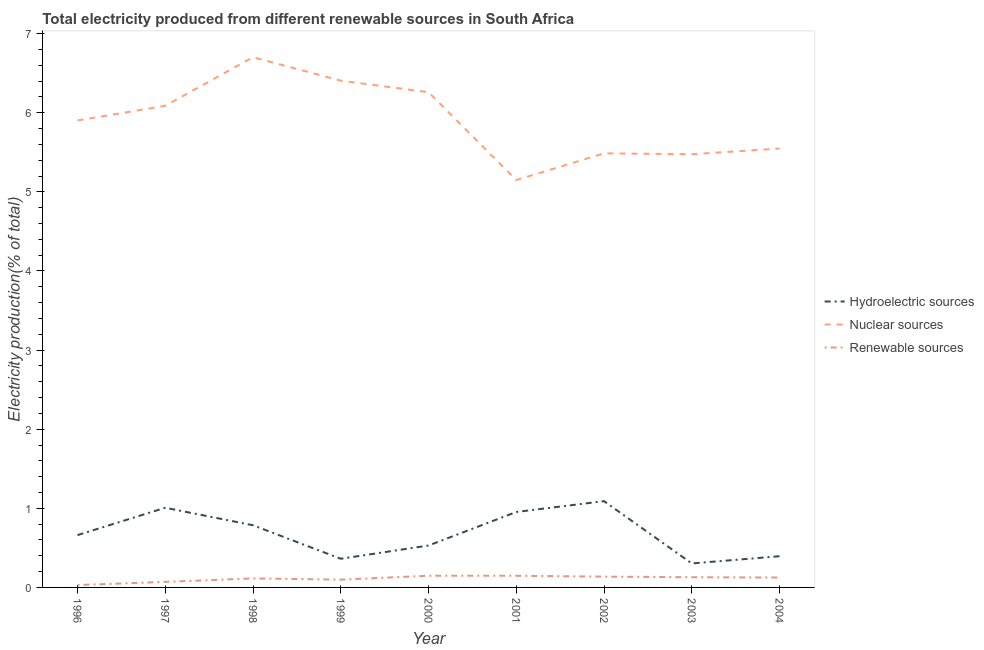Does the line corresponding to percentage of electricity produced by renewable sources intersect with the line corresponding to percentage of electricity produced by hydroelectric sources?
Make the answer very short. No. Is the number of lines equal to the number of legend labels?
Your answer should be very brief. Yes. What is the percentage of electricity produced by hydroelectric sources in 2002?
Provide a succinct answer. 1.09. Across all years, what is the maximum percentage of electricity produced by renewable sources?
Your response must be concise. 0.15. Across all years, what is the minimum percentage of electricity produced by nuclear sources?
Your response must be concise. 5.15. In which year was the percentage of electricity produced by renewable sources minimum?
Offer a terse response. 1996. What is the total percentage of electricity produced by hydroelectric sources in the graph?
Your answer should be compact. 6.09. What is the difference between the percentage of electricity produced by nuclear sources in 1997 and that in 2001?
Ensure brevity in your answer.  0.94. What is the difference between the percentage of electricity produced by renewable sources in 1997 and the percentage of electricity produced by hydroelectric sources in 1998?
Offer a very short reply. -0.72. What is the average percentage of electricity produced by hydroelectric sources per year?
Offer a very short reply. 0.68. In the year 1997, what is the difference between the percentage of electricity produced by hydroelectric sources and percentage of electricity produced by renewable sources?
Ensure brevity in your answer.  0.94. In how many years, is the percentage of electricity produced by hydroelectric sources greater than 2.8 %?
Your answer should be compact. 0. What is the ratio of the percentage of electricity produced by hydroelectric sources in 1996 to that in 1998?
Provide a succinct answer. 0.84. Is the percentage of electricity produced by nuclear sources in 2000 less than that in 2004?
Make the answer very short. No. What is the difference between the highest and the second highest percentage of electricity produced by hydroelectric sources?
Your response must be concise. 0.08. What is the difference between the highest and the lowest percentage of electricity produced by renewable sources?
Ensure brevity in your answer.  0.12. In how many years, is the percentage of electricity produced by hydroelectric sources greater than the average percentage of electricity produced by hydroelectric sources taken over all years?
Offer a very short reply. 4. Is the sum of the percentage of electricity produced by nuclear sources in 1998 and 1999 greater than the maximum percentage of electricity produced by hydroelectric sources across all years?
Your response must be concise. Yes. Does the percentage of electricity produced by hydroelectric sources monotonically increase over the years?
Provide a short and direct response. No. Is the percentage of electricity produced by renewable sources strictly greater than the percentage of electricity produced by hydroelectric sources over the years?
Keep it short and to the point. No. Is the percentage of electricity produced by nuclear sources strictly less than the percentage of electricity produced by hydroelectric sources over the years?
Offer a very short reply. No. How many lines are there?
Give a very brief answer. 3. How many years are there in the graph?
Offer a very short reply. 9. Are the values on the major ticks of Y-axis written in scientific E-notation?
Your answer should be compact. No. Does the graph contain any zero values?
Make the answer very short. No. How many legend labels are there?
Provide a short and direct response. 3. What is the title of the graph?
Offer a terse response. Total electricity produced from different renewable sources in South Africa. Does "Liquid fuel" appear as one of the legend labels in the graph?
Offer a terse response. No. What is the label or title of the X-axis?
Your answer should be compact. Year. What is the Electricity production(% of total) of Hydroelectric sources in 1996?
Make the answer very short. 0.66. What is the Electricity production(% of total) of Nuclear sources in 1996?
Offer a terse response. 5.9. What is the Electricity production(% of total) in Renewable sources in 1996?
Your answer should be compact. 0.03. What is the Electricity production(% of total) of Hydroelectric sources in 1997?
Ensure brevity in your answer.  1.01. What is the Electricity production(% of total) of Nuclear sources in 1997?
Provide a short and direct response. 6.09. What is the Electricity production(% of total) of Renewable sources in 1997?
Your answer should be very brief. 0.07. What is the Electricity production(% of total) of Hydroelectric sources in 1998?
Give a very brief answer. 0.79. What is the Electricity production(% of total) in Nuclear sources in 1998?
Give a very brief answer. 6.7. What is the Electricity production(% of total) of Renewable sources in 1998?
Make the answer very short. 0.11. What is the Electricity production(% of total) in Hydroelectric sources in 1999?
Offer a terse response. 0.36. What is the Electricity production(% of total) of Nuclear sources in 1999?
Give a very brief answer. 6.4. What is the Electricity production(% of total) in Renewable sources in 1999?
Make the answer very short. 0.1. What is the Electricity production(% of total) of Hydroelectric sources in 2000?
Provide a short and direct response. 0.53. What is the Electricity production(% of total) in Nuclear sources in 2000?
Your answer should be compact. 6.26. What is the Electricity production(% of total) in Renewable sources in 2000?
Keep it short and to the point. 0.15. What is the Electricity production(% of total) in Hydroelectric sources in 2001?
Provide a short and direct response. 0.95. What is the Electricity production(% of total) of Nuclear sources in 2001?
Ensure brevity in your answer.  5.15. What is the Electricity production(% of total) in Renewable sources in 2001?
Make the answer very short. 0.15. What is the Electricity production(% of total) in Hydroelectric sources in 2002?
Provide a short and direct response. 1.09. What is the Electricity production(% of total) of Nuclear sources in 2002?
Keep it short and to the point. 5.49. What is the Electricity production(% of total) in Renewable sources in 2002?
Give a very brief answer. 0.14. What is the Electricity production(% of total) of Hydroelectric sources in 2003?
Provide a short and direct response. 0.3. What is the Electricity production(% of total) of Nuclear sources in 2003?
Give a very brief answer. 5.48. What is the Electricity production(% of total) of Renewable sources in 2003?
Ensure brevity in your answer.  0.13. What is the Electricity production(% of total) of Hydroelectric sources in 2004?
Your response must be concise. 0.39. What is the Electricity production(% of total) in Nuclear sources in 2004?
Your answer should be compact. 5.55. What is the Electricity production(% of total) of Renewable sources in 2004?
Offer a very short reply. 0.12. Across all years, what is the maximum Electricity production(% of total) of Hydroelectric sources?
Give a very brief answer. 1.09. Across all years, what is the maximum Electricity production(% of total) of Nuclear sources?
Your response must be concise. 6.7. Across all years, what is the maximum Electricity production(% of total) in Renewable sources?
Provide a short and direct response. 0.15. Across all years, what is the minimum Electricity production(% of total) of Hydroelectric sources?
Your response must be concise. 0.3. Across all years, what is the minimum Electricity production(% of total) in Nuclear sources?
Your answer should be very brief. 5.15. Across all years, what is the minimum Electricity production(% of total) in Renewable sources?
Your answer should be very brief. 0.03. What is the total Electricity production(% of total) of Hydroelectric sources in the graph?
Provide a short and direct response. 6.09. What is the total Electricity production(% of total) of Nuclear sources in the graph?
Make the answer very short. 53.01. What is the difference between the Electricity production(% of total) in Hydroelectric sources in 1996 and that in 1997?
Your answer should be compact. -0.35. What is the difference between the Electricity production(% of total) in Nuclear sources in 1996 and that in 1997?
Offer a very short reply. -0.19. What is the difference between the Electricity production(% of total) in Renewable sources in 1996 and that in 1997?
Keep it short and to the point. -0.04. What is the difference between the Electricity production(% of total) of Hydroelectric sources in 1996 and that in 1998?
Ensure brevity in your answer.  -0.12. What is the difference between the Electricity production(% of total) of Nuclear sources in 1996 and that in 1998?
Offer a terse response. -0.8. What is the difference between the Electricity production(% of total) of Renewable sources in 1996 and that in 1998?
Your answer should be compact. -0.08. What is the difference between the Electricity production(% of total) of Hydroelectric sources in 1996 and that in 1999?
Provide a succinct answer. 0.3. What is the difference between the Electricity production(% of total) in Nuclear sources in 1996 and that in 1999?
Give a very brief answer. -0.5. What is the difference between the Electricity production(% of total) in Renewable sources in 1996 and that in 1999?
Your answer should be compact. -0.07. What is the difference between the Electricity production(% of total) of Hydroelectric sources in 1996 and that in 2000?
Provide a succinct answer. 0.13. What is the difference between the Electricity production(% of total) of Nuclear sources in 1996 and that in 2000?
Give a very brief answer. -0.36. What is the difference between the Electricity production(% of total) in Renewable sources in 1996 and that in 2000?
Keep it short and to the point. -0.12. What is the difference between the Electricity production(% of total) in Hydroelectric sources in 1996 and that in 2001?
Your answer should be compact. -0.29. What is the difference between the Electricity production(% of total) of Nuclear sources in 1996 and that in 2001?
Ensure brevity in your answer.  0.75. What is the difference between the Electricity production(% of total) in Renewable sources in 1996 and that in 2001?
Provide a succinct answer. -0.12. What is the difference between the Electricity production(% of total) in Hydroelectric sources in 1996 and that in 2002?
Your answer should be compact. -0.43. What is the difference between the Electricity production(% of total) in Nuclear sources in 1996 and that in 2002?
Keep it short and to the point. 0.42. What is the difference between the Electricity production(% of total) of Renewable sources in 1996 and that in 2002?
Your answer should be compact. -0.11. What is the difference between the Electricity production(% of total) in Hydroelectric sources in 1996 and that in 2003?
Offer a very short reply. 0.36. What is the difference between the Electricity production(% of total) in Nuclear sources in 1996 and that in 2003?
Provide a short and direct response. 0.43. What is the difference between the Electricity production(% of total) in Renewable sources in 1996 and that in 2003?
Give a very brief answer. -0.1. What is the difference between the Electricity production(% of total) of Hydroelectric sources in 1996 and that in 2004?
Offer a very short reply. 0.27. What is the difference between the Electricity production(% of total) of Nuclear sources in 1996 and that in 2004?
Your response must be concise. 0.36. What is the difference between the Electricity production(% of total) in Renewable sources in 1996 and that in 2004?
Ensure brevity in your answer.  -0.09. What is the difference between the Electricity production(% of total) of Hydroelectric sources in 1997 and that in 1998?
Make the answer very short. 0.22. What is the difference between the Electricity production(% of total) in Nuclear sources in 1997 and that in 1998?
Your response must be concise. -0.61. What is the difference between the Electricity production(% of total) of Renewable sources in 1997 and that in 1998?
Offer a very short reply. -0.04. What is the difference between the Electricity production(% of total) in Hydroelectric sources in 1997 and that in 1999?
Provide a succinct answer. 0.64. What is the difference between the Electricity production(% of total) of Nuclear sources in 1997 and that in 1999?
Offer a very short reply. -0.32. What is the difference between the Electricity production(% of total) in Renewable sources in 1997 and that in 1999?
Provide a short and direct response. -0.03. What is the difference between the Electricity production(% of total) in Hydroelectric sources in 1997 and that in 2000?
Your response must be concise. 0.48. What is the difference between the Electricity production(% of total) in Nuclear sources in 1997 and that in 2000?
Offer a terse response. -0.17. What is the difference between the Electricity production(% of total) of Renewable sources in 1997 and that in 2000?
Keep it short and to the point. -0.08. What is the difference between the Electricity production(% of total) of Hydroelectric sources in 1997 and that in 2001?
Provide a succinct answer. 0.05. What is the difference between the Electricity production(% of total) in Nuclear sources in 1997 and that in 2001?
Your answer should be compact. 0.94. What is the difference between the Electricity production(% of total) in Renewable sources in 1997 and that in 2001?
Provide a short and direct response. -0.08. What is the difference between the Electricity production(% of total) of Hydroelectric sources in 1997 and that in 2002?
Provide a short and direct response. -0.08. What is the difference between the Electricity production(% of total) of Nuclear sources in 1997 and that in 2002?
Provide a succinct answer. 0.6. What is the difference between the Electricity production(% of total) of Renewable sources in 1997 and that in 2002?
Your answer should be very brief. -0.07. What is the difference between the Electricity production(% of total) in Hydroelectric sources in 1997 and that in 2003?
Give a very brief answer. 0.7. What is the difference between the Electricity production(% of total) of Nuclear sources in 1997 and that in 2003?
Offer a terse response. 0.61. What is the difference between the Electricity production(% of total) in Renewable sources in 1997 and that in 2003?
Provide a short and direct response. -0.06. What is the difference between the Electricity production(% of total) in Hydroelectric sources in 1997 and that in 2004?
Your response must be concise. 0.61. What is the difference between the Electricity production(% of total) of Nuclear sources in 1997 and that in 2004?
Offer a very short reply. 0.54. What is the difference between the Electricity production(% of total) of Renewable sources in 1997 and that in 2004?
Make the answer very short. -0.05. What is the difference between the Electricity production(% of total) of Hydroelectric sources in 1998 and that in 1999?
Make the answer very short. 0.42. What is the difference between the Electricity production(% of total) of Nuclear sources in 1998 and that in 1999?
Provide a succinct answer. 0.3. What is the difference between the Electricity production(% of total) of Renewable sources in 1998 and that in 1999?
Your response must be concise. 0.02. What is the difference between the Electricity production(% of total) in Hydroelectric sources in 1998 and that in 2000?
Ensure brevity in your answer.  0.26. What is the difference between the Electricity production(% of total) of Nuclear sources in 1998 and that in 2000?
Keep it short and to the point. 0.44. What is the difference between the Electricity production(% of total) in Renewable sources in 1998 and that in 2000?
Your answer should be compact. -0.03. What is the difference between the Electricity production(% of total) in Hydroelectric sources in 1998 and that in 2001?
Provide a short and direct response. -0.17. What is the difference between the Electricity production(% of total) of Nuclear sources in 1998 and that in 2001?
Ensure brevity in your answer.  1.55. What is the difference between the Electricity production(% of total) in Renewable sources in 1998 and that in 2001?
Offer a terse response. -0.03. What is the difference between the Electricity production(% of total) of Hydroelectric sources in 1998 and that in 2002?
Your answer should be very brief. -0.3. What is the difference between the Electricity production(% of total) of Nuclear sources in 1998 and that in 2002?
Provide a succinct answer. 1.22. What is the difference between the Electricity production(% of total) in Renewable sources in 1998 and that in 2002?
Your answer should be very brief. -0.02. What is the difference between the Electricity production(% of total) in Hydroelectric sources in 1998 and that in 2003?
Make the answer very short. 0.48. What is the difference between the Electricity production(% of total) in Nuclear sources in 1998 and that in 2003?
Ensure brevity in your answer.  1.23. What is the difference between the Electricity production(% of total) in Renewable sources in 1998 and that in 2003?
Your answer should be compact. -0.01. What is the difference between the Electricity production(% of total) in Hydroelectric sources in 1998 and that in 2004?
Make the answer very short. 0.39. What is the difference between the Electricity production(% of total) in Nuclear sources in 1998 and that in 2004?
Give a very brief answer. 1.15. What is the difference between the Electricity production(% of total) in Renewable sources in 1998 and that in 2004?
Provide a succinct answer. -0.01. What is the difference between the Electricity production(% of total) in Hydroelectric sources in 1999 and that in 2000?
Your response must be concise. -0.17. What is the difference between the Electricity production(% of total) in Nuclear sources in 1999 and that in 2000?
Your answer should be compact. 0.15. What is the difference between the Electricity production(% of total) of Renewable sources in 1999 and that in 2000?
Provide a short and direct response. -0.05. What is the difference between the Electricity production(% of total) in Hydroelectric sources in 1999 and that in 2001?
Your response must be concise. -0.59. What is the difference between the Electricity production(% of total) in Nuclear sources in 1999 and that in 2001?
Provide a short and direct response. 1.26. What is the difference between the Electricity production(% of total) of Renewable sources in 1999 and that in 2001?
Your answer should be very brief. -0.05. What is the difference between the Electricity production(% of total) of Hydroelectric sources in 1999 and that in 2002?
Provide a succinct answer. -0.73. What is the difference between the Electricity production(% of total) in Nuclear sources in 1999 and that in 2002?
Make the answer very short. 0.92. What is the difference between the Electricity production(% of total) of Renewable sources in 1999 and that in 2002?
Your response must be concise. -0.04. What is the difference between the Electricity production(% of total) in Hydroelectric sources in 1999 and that in 2003?
Give a very brief answer. 0.06. What is the difference between the Electricity production(% of total) in Nuclear sources in 1999 and that in 2003?
Ensure brevity in your answer.  0.93. What is the difference between the Electricity production(% of total) of Renewable sources in 1999 and that in 2003?
Provide a succinct answer. -0.03. What is the difference between the Electricity production(% of total) in Hydroelectric sources in 1999 and that in 2004?
Provide a succinct answer. -0.03. What is the difference between the Electricity production(% of total) of Nuclear sources in 1999 and that in 2004?
Ensure brevity in your answer.  0.86. What is the difference between the Electricity production(% of total) in Renewable sources in 1999 and that in 2004?
Give a very brief answer. -0.03. What is the difference between the Electricity production(% of total) in Hydroelectric sources in 2000 and that in 2001?
Ensure brevity in your answer.  -0.42. What is the difference between the Electricity production(% of total) of Nuclear sources in 2000 and that in 2001?
Provide a succinct answer. 1.11. What is the difference between the Electricity production(% of total) of Hydroelectric sources in 2000 and that in 2002?
Keep it short and to the point. -0.56. What is the difference between the Electricity production(% of total) in Nuclear sources in 2000 and that in 2002?
Your response must be concise. 0.77. What is the difference between the Electricity production(% of total) of Renewable sources in 2000 and that in 2002?
Provide a succinct answer. 0.01. What is the difference between the Electricity production(% of total) in Hydroelectric sources in 2000 and that in 2003?
Provide a succinct answer. 0.23. What is the difference between the Electricity production(% of total) in Nuclear sources in 2000 and that in 2003?
Keep it short and to the point. 0.78. What is the difference between the Electricity production(% of total) in Renewable sources in 2000 and that in 2003?
Offer a very short reply. 0.02. What is the difference between the Electricity production(% of total) in Hydroelectric sources in 2000 and that in 2004?
Provide a short and direct response. 0.14. What is the difference between the Electricity production(% of total) of Nuclear sources in 2000 and that in 2004?
Keep it short and to the point. 0.71. What is the difference between the Electricity production(% of total) of Renewable sources in 2000 and that in 2004?
Make the answer very short. 0.02. What is the difference between the Electricity production(% of total) in Hydroelectric sources in 2001 and that in 2002?
Your answer should be very brief. -0.14. What is the difference between the Electricity production(% of total) of Nuclear sources in 2001 and that in 2002?
Offer a very short reply. -0.34. What is the difference between the Electricity production(% of total) of Renewable sources in 2001 and that in 2002?
Your answer should be compact. 0.01. What is the difference between the Electricity production(% of total) of Hydroelectric sources in 2001 and that in 2003?
Your answer should be very brief. 0.65. What is the difference between the Electricity production(% of total) of Nuclear sources in 2001 and that in 2003?
Your answer should be compact. -0.33. What is the difference between the Electricity production(% of total) of Renewable sources in 2001 and that in 2003?
Provide a succinct answer. 0.02. What is the difference between the Electricity production(% of total) of Hydroelectric sources in 2001 and that in 2004?
Give a very brief answer. 0.56. What is the difference between the Electricity production(% of total) in Nuclear sources in 2001 and that in 2004?
Your response must be concise. -0.4. What is the difference between the Electricity production(% of total) in Renewable sources in 2001 and that in 2004?
Your answer should be very brief. 0.02. What is the difference between the Electricity production(% of total) of Hydroelectric sources in 2002 and that in 2003?
Your answer should be very brief. 0.79. What is the difference between the Electricity production(% of total) in Nuclear sources in 2002 and that in 2003?
Your answer should be compact. 0.01. What is the difference between the Electricity production(% of total) of Renewable sources in 2002 and that in 2003?
Your answer should be compact. 0.01. What is the difference between the Electricity production(% of total) in Hydroelectric sources in 2002 and that in 2004?
Keep it short and to the point. 0.7. What is the difference between the Electricity production(% of total) of Nuclear sources in 2002 and that in 2004?
Provide a succinct answer. -0.06. What is the difference between the Electricity production(% of total) of Renewable sources in 2002 and that in 2004?
Keep it short and to the point. 0.01. What is the difference between the Electricity production(% of total) of Hydroelectric sources in 2003 and that in 2004?
Your answer should be compact. -0.09. What is the difference between the Electricity production(% of total) of Nuclear sources in 2003 and that in 2004?
Your answer should be compact. -0.07. What is the difference between the Electricity production(% of total) of Renewable sources in 2003 and that in 2004?
Provide a short and direct response. 0. What is the difference between the Electricity production(% of total) of Hydroelectric sources in 1996 and the Electricity production(% of total) of Nuclear sources in 1997?
Make the answer very short. -5.43. What is the difference between the Electricity production(% of total) of Hydroelectric sources in 1996 and the Electricity production(% of total) of Renewable sources in 1997?
Your answer should be very brief. 0.59. What is the difference between the Electricity production(% of total) in Nuclear sources in 1996 and the Electricity production(% of total) in Renewable sources in 1997?
Offer a terse response. 5.83. What is the difference between the Electricity production(% of total) in Hydroelectric sources in 1996 and the Electricity production(% of total) in Nuclear sources in 1998?
Your answer should be very brief. -6.04. What is the difference between the Electricity production(% of total) in Hydroelectric sources in 1996 and the Electricity production(% of total) in Renewable sources in 1998?
Offer a very short reply. 0.55. What is the difference between the Electricity production(% of total) of Nuclear sources in 1996 and the Electricity production(% of total) of Renewable sources in 1998?
Your response must be concise. 5.79. What is the difference between the Electricity production(% of total) in Hydroelectric sources in 1996 and the Electricity production(% of total) in Nuclear sources in 1999?
Ensure brevity in your answer.  -5.74. What is the difference between the Electricity production(% of total) of Hydroelectric sources in 1996 and the Electricity production(% of total) of Renewable sources in 1999?
Offer a very short reply. 0.56. What is the difference between the Electricity production(% of total) of Nuclear sources in 1996 and the Electricity production(% of total) of Renewable sources in 1999?
Give a very brief answer. 5.8. What is the difference between the Electricity production(% of total) in Hydroelectric sources in 1996 and the Electricity production(% of total) in Nuclear sources in 2000?
Your response must be concise. -5.6. What is the difference between the Electricity production(% of total) of Hydroelectric sources in 1996 and the Electricity production(% of total) of Renewable sources in 2000?
Keep it short and to the point. 0.51. What is the difference between the Electricity production(% of total) of Nuclear sources in 1996 and the Electricity production(% of total) of Renewable sources in 2000?
Offer a very short reply. 5.75. What is the difference between the Electricity production(% of total) in Hydroelectric sources in 1996 and the Electricity production(% of total) in Nuclear sources in 2001?
Your answer should be very brief. -4.49. What is the difference between the Electricity production(% of total) of Hydroelectric sources in 1996 and the Electricity production(% of total) of Renewable sources in 2001?
Provide a short and direct response. 0.51. What is the difference between the Electricity production(% of total) of Nuclear sources in 1996 and the Electricity production(% of total) of Renewable sources in 2001?
Provide a succinct answer. 5.75. What is the difference between the Electricity production(% of total) in Hydroelectric sources in 1996 and the Electricity production(% of total) in Nuclear sources in 2002?
Provide a short and direct response. -4.83. What is the difference between the Electricity production(% of total) of Hydroelectric sources in 1996 and the Electricity production(% of total) of Renewable sources in 2002?
Your answer should be very brief. 0.52. What is the difference between the Electricity production(% of total) of Nuclear sources in 1996 and the Electricity production(% of total) of Renewable sources in 2002?
Make the answer very short. 5.77. What is the difference between the Electricity production(% of total) of Hydroelectric sources in 1996 and the Electricity production(% of total) of Nuclear sources in 2003?
Keep it short and to the point. -4.81. What is the difference between the Electricity production(% of total) of Hydroelectric sources in 1996 and the Electricity production(% of total) of Renewable sources in 2003?
Make the answer very short. 0.53. What is the difference between the Electricity production(% of total) in Nuclear sources in 1996 and the Electricity production(% of total) in Renewable sources in 2003?
Provide a short and direct response. 5.77. What is the difference between the Electricity production(% of total) in Hydroelectric sources in 1996 and the Electricity production(% of total) in Nuclear sources in 2004?
Your response must be concise. -4.89. What is the difference between the Electricity production(% of total) in Hydroelectric sources in 1996 and the Electricity production(% of total) in Renewable sources in 2004?
Offer a terse response. 0.54. What is the difference between the Electricity production(% of total) in Nuclear sources in 1996 and the Electricity production(% of total) in Renewable sources in 2004?
Provide a short and direct response. 5.78. What is the difference between the Electricity production(% of total) in Hydroelectric sources in 1997 and the Electricity production(% of total) in Nuclear sources in 1998?
Provide a short and direct response. -5.69. What is the difference between the Electricity production(% of total) of Hydroelectric sources in 1997 and the Electricity production(% of total) of Renewable sources in 1998?
Provide a succinct answer. 0.89. What is the difference between the Electricity production(% of total) in Nuclear sources in 1997 and the Electricity production(% of total) in Renewable sources in 1998?
Offer a very short reply. 5.97. What is the difference between the Electricity production(% of total) in Hydroelectric sources in 1997 and the Electricity production(% of total) in Nuclear sources in 1999?
Provide a succinct answer. -5.4. What is the difference between the Electricity production(% of total) in Hydroelectric sources in 1997 and the Electricity production(% of total) in Renewable sources in 1999?
Your answer should be very brief. 0.91. What is the difference between the Electricity production(% of total) of Nuclear sources in 1997 and the Electricity production(% of total) of Renewable sources in 1999?
Provide a short and direct response. 5.99. What is the difference between the Electricity production(% of total) of Hydroelectric sources in 1997 and the Electricity production(% of total) of Nuclear sources in 2000?
Your answer should be very brief. -5.25. What is the difference between the Electricity production(% of total) of Hydroelectric sources in 1997 and the Electricity production(% of total) of Renewable sources in 2000?
Offer a very short reply. 0.86. What is the difference between the Electricity production(% of total) in Nuclear sources in 1997 and the Electricity production(% of total) in Renewable sources in 2000?
Offer a very short reply. 5.94. What is the difference between the Electricity production(% of total) of Hydroelectric sources in 1997 and the Electricity production(% of total) of Nuclear sources in 2001?
Ensure brevity in your answer.  -4.14. What is the difference between the Electricity production(% of total) of Hydroelectric sources in 1997 and the Electricity production(% of total) of Renewable sources in 2001?
Provide a short and direct response. 0.86. What is the difference between the Electricity production(% of total) in Nuclear sources in 1997 and the Electricity production(% of total) in Renewable sources in 2001?
Your response must be concise. 5.94. What is the difference between the Electricity production(% of total) of Hydroelectric sources in 1997 and the Electricity production(% of total) of Nuclear sources in 2002?
Offer a very short reply. -4.48. What is the difference between the Electricity production(% of total) in Hydroelectric sources in 1997 and the Electricity production(% of total) in Renewable sources in 2002?
Ensure brevity in your answer.  0.87. What is the difference between the Electricity production(% of total) in Nuclear sources in 1997 and the Electricity production(% of total) in Renewable sources in 2002?
Make the answer very short. 5.95. What is the difference between the Electricity production(% of total) in Hydroelectric sources in 1997 and the Electricity production(% of total) in Nuclear sources in 2003?
Provide a succinct answer. -4.47. What is the difference between the Electricity production(% of total) of Hydroelectric sources in 1997 and the Electricity production(% of total) of Renewable sources in 2003?
Your response must be concise. 0.88. What is the difference between the Electricity production(% of total) in Nuclear sources in 1997 and the Electricity production(% of total) in Renewable sources in 2003?
Give a very brief answer. 5.96. What is the difference between the Electricity production(% of total) of Hydroelectric sources in 1997 and the Electricity production(% of total) of Nuclear sources in 2004?
Your answer should be very brief. -4.54. What is the difference between the Electricity production(% of total) in Hydroelectric sources in 1997 and the Electricity production(% of total) in Renewable sources in 2004?
Offer a terse response. 0.88. What is the difference between the Electricity production(% of total) of Nuclear sources in 1997 and the Electricity production(% of total) of Renewable sources in 2004?
Your response must be concise. 5.96. What is the difference between the Electricity production(% of total) in Hydroelectric sources in 1998 and the Electricity production(% of total) in Nuclear sources in 1999?
Provide a short and direct response. -5.62. What is the difference between the Electricity production(% of total) in Hydroelectric sources in 1998 and the Electricity production(% of total) in Renewable sources in 1999?
Offer a very short reply. 0.69. What is the difference between the Electricity production(% of total) of Nuclear sources in 1998 and the Electricity production(% of total) of Renewable sources in 1999?
Give a very brief answer. 6.6. What is the difference between the Electricity production(% of total) in Hydroelectric sources in 1998 and the Electricity production(% of total) in Nuclear sources in 2000?
Make the answer very short. -5.47. What is the difference between the Electricity production(% of total) of Hydroelectric sources in 1998 and the Electricity production(% of total) of Renewable sources in 2000?
Offer a very short reply. 0.64. What is the difference between the Electricity production(% of total) of Nuclear sources in 1998 and the Electricity production(% of total) of Renewable sources in 2000?
Give a very brief answer. 6.55. What is the difference between the Electricity production(% of total) in Hydroelectric sources in 1998 and the Electricity production(% of total) in Nuclear sources in 2001?
Your answer should be very brief. -4.36. What is the difference between the Electricity production(% of total) in Hydroelectric sources in 1998 and the Electricity production(% of total) in Renewable sources in 2001?
Keep it short and to the point. 0.64. What is the difference between the Electricity production(% of total) in Nuclear sources in 1998 and the Electricity production(% of total) in Renewable sources in 2001?
Offer a terse response. 6.55. What is the difference between the Electricity production(% of total) of Hydroelectric sources in 1998 and the Electricity production(% of total) of Nuclear sources in 2002?
Provide a short and direct response. -4.7. What is the difference between the Electricity production(% of total) in Hydroelectric sources in 1998 and the Electricity production(% of total) in Renewable sources in 2002?
Give a very brief answer. 0.65. What is the difference between the Electricity production(% of total) in Nuclear sources in 1998 and the Electricity production(% of total) in Renewable sources in 2002?
Provide a succinct answer. 6.57. What is the difference between the Electricity production(% of total) of Hydroelectric sources in 1998 and the Electricity production(% of total) of Nuclear sources in 2003?
Offer a very short reply. -4.69. What is the difference between the Electricity production(% of total) in Hydroelectric sources in 1998 and the Electricity production(% of total) in Renewable sources in 2003?
Offer a terse response. 0.66. What is the difference between the Electricity production(% of total) of Nuclear sources in 1998 and the Electricity production(% of total) of Renewable sources in 2003?
Keep it short and to the point. 6.57. What is the difference between the Electricity production(% of total) in Hydroelectric sources in 1998 and the Electricity production(% of total) in Nuclear sources in 2004?
Your answer should be compact. -4.76. What is the difference between the Electricity production(% of total) in Hydroelectric sources in 1998 and the Electricity production(% of total) in Renewable sources in 2004?
Offer a terse response. 0.66. What is the difference between the Electricity production(% of total) in Nuclear sources in 1998 and the Electricity production(% of total) in Renewable sources in 2004?
Your answer should be very brief. 6.58. What is the difference between the Electricity production(% of total) of Hydroelectric sources in 1999 and the Electricity production(% of total) of Nuclear sources in 2000?
Provide a succinct answer. -5.9. What is the difference between the Electricity production(% of total) of Hydroelectric sources in 1999 and the Electricity production(% of total) of Renewable sources in 2000?
Provide a short and direct response. 0.21. What is the difference between the Electricity production(% of total) of Nuclear sources in 1999 and the Electricity production(% of total) of Renewable sources in 2000?
Give a very brief answer. 6.26. What is the difference between the Electricity production(% of total) in Hydroelectric sources in 1999 and the Electricity production(% of total) in Nuclear sources in 2001?
Make the answer very short. -4.79. What is the difference between the Electricity production(% of total) in Hydroelectric sources in 1999 and the Electricity production(% of total) in Renewable sources in 2001?
Your answer should be compact. 0.21. What is the difference between the Electricity production(% of total) in Nuclear sources in 1999 and the Electricity production(% of total) in Renewable sources in 2001?
Make the answer very short. 6.26. What is the difference between the Electricity production(% of total) of Hydroelectric sources in 1999 and the Electricity production(% of total) of Nuclear sources in 2002?
Keep it short and to the point. -5.12. What is the difference between the Electricity production(% of total) of Hydroelectric sources in 1999 and the Electricity production(% of total) of Renewable sources in 2002?
Your answer should be compact. 0.23. What is the difference between the Electricity production(% of total) in Nuclear sources in 1999 and the Electricity production(% of total) in Renewable sources in 2002?
Offer a very short reply. 6.27. What is the difference between the Electricity production(% of total) of Hydroelectric sources in 1999 and the Electricity production(% of total) of Nuclear sources in 2003?
Offer a terse response. -5.11. What is the difference between the Electricity production(% of total) of Hydroelectric sources in 1999 and the Electricity production(% of total) of Renewable sources in 2003?
Offer a very short reply. 0.23. What is the difference between the Electricity production(% of total) in Nuclear sources in 1999 and the Electricity production(% of total) in Renewable sources in 2003?
Ensure brevity in your answer.  6.28. What is the difference between the Electricity production(% of total) of Hydroelectric sources in 1999 and the Electricity production(% of total) of Nuclear sources in 2004?
Offer a terse response. -5.18. What is the difference between the Electricity production(% of total) of Hydroelectric sources in 1999 and the Electricity production(% of total) of Renewable sources in 2004?
Give a very brief answer. 0.24. What is the difference between the Electricity production(% of total) in Nuclear sources in 1999 and the Electricity production(% of total) in Renewable sources in 2004?
Offer a terse response. 6.28. What is the difference between the Electricity production(% of total) in Hydroelectric sources in 2000 and the Electricity production(% of total) in Nuclear sources in 2001?
Provide a succinct answer. -4.62. What is the difference between the Electricity production(% of total) in Hydroelectric sources in 2000 and the Electricity production(% of total) in Renewable sources in 2001?
Give a very brief answer. 0.38. What is the difference between the Electricity production(% of total) of Nuclear sources in 2000 and the Electricity production(% of total) of Renewable sources in 2001?
Offer a very short reply. 6.11. What is the difference between the Electricity production(% of total) of Hydroelectric sources in 2000 and the Electricity production(% of total) of Nuclear sources in 2002?
Provide a succinct answer. -4.96. What is the difference between the Electricity production(% of total) of Hydroelectric sources in 2000 and the Electricity production(% of total) of Renewable sources in 2002?
Your answer should be compact. 0.39. What is the difference between the Electricity production(% of total) of Nuclear sources in 2000 and the Electricity production(% of total) of Renewable sources in 2002?
Provide a succinct answer. 6.12. What is the difference between the Electricity production(% of total) in Hydroelectric sources in 2000 and the Electricity production(% of total) in Nuclear sources in 2003?
Give a very brief answer. -4.95. What is the difference between the Electricity production(% of total) of Hydroelectric sources in 2000 and the Electricity production(% of total) of Renewable sources in 2003?
Provide a short and direct response. 0.4. What is the difference between the Electricity production(% of total) of Nuclear sources in 2000 and the Electricity production(% of total) of Renewable sources in 2003?
Ensure brevity in your answer.  6.13. What is the difference between the Electricity production(% of total) in Hydroelectric sources in 2000 and the Electricity production(% of total) in Nuclear sources in 2004?
Give a very brief answer. -5.02. What is the difference between the Electricity production(% of total) in Hydroelectric sources in 2000 and the Electricity production(% of total) in Renewable sources in 2004?
Provide a short and direct response. 0.4. What is the difference between the Electricity production(% of total) of Nuclear sources in 2000 and the Electricity production(% of total) of Renewable sources in 2004?
Make the answer very short. 6.13. What is the difference between the Electricity production(% of total) in Hydroelectric sources in 2001 and the Electricity production(% of total) in Nuclear sources in 2002?
Offer a very short reply. -4.53. What is the difference between the Electricity production(% of total) in Hydroelectric sources in 2001 and the Electricity production(% of total) in Renewable sources in 2002?
Keep it short and to the point. 0.82. What is the difference between the Electricity production(% of total) of Nuclear sources in 2001 and the Electricity production(% of total) of Renewable sources in 2002?
Ensure brevity in your answer.  5.01. What is the difference between the Electricity production(% of total) of Hydroelectric sources in 2001 and the Electricity production(% of total) of Nuclear sources in 2003?
Ensure brevity in your answer.  -4.52. What is the difference between the Electricity production(% of total) of Hydroelectric sources in 2001 and the Electricity production(% of total) of Renewable sources in 2003?
Offer a very short reply. 0.82. What is the difference between the Electricity production(% of total) in Nuclear sources in 2001 and the Electricity production(% of total) in Renewable sources in 2003?
Keep it short and to the point. 5.02. What is the difference between the Electricity production(% of total) in Hydroelectric sources in 2001 and the Electricity production(% of total) in Nuclear sources in 2004?
Your response must be concise. -4.59. What is the difference between the Electricity production(% of total) of Hydroelectric sources in 2001 and the Electricity production(% of total) of Renewable sources in 2004?
Your answer should be very brief. 0.83. What is the difference between the Electricity production(% of total) in Nuclear sources in 2001 and the Electricity production(% of total) in Renewable sources in 2004?
Offer a very short reply. 5.02. What is the difference between the Electricity production(% of total) in Hydroelectric sources in 2002 and the Electricity production(% of total) in Nuclear sources in 2003?
Offer a terse response. -4.39. What is the difference between the Electricity production(% of total) in Hydroelectric sources in 2002 and the Electricity production(% of total) in Renewable sources in 2003?
Keep it short and to the point. 0.96. What is the difference between the Electricity production(% of total) in Nuclear sources in 2002 and the Electricity production(% of total) in Renewable sources in 2003?
Your response must be concise. 5.36. What is the difference between the Electricity production(% of total) in Hydroelectric sources in 2002 and the Electricity production(% of total) in Nuclear sources in 2004?
Ensure brevity in your answer.  -4.46. What is the difference between the Electricity production(% of total) of Hydroelectric sources in 2002 and the Electricity production(% of total) of Renewable sources in 2004?
Keep it short and to the point. 0.97. What is the difference between the Electricity production(% of total) in Nuclear sources in 2002 and the Electricity production(% of total) in Renewable sources in 2004?
Your answer should be compact. 5.36. What is the difference between the Electricity production(% of total) of Hydroelectric sources in 2003 and the Electricity production(% of total) of Nuclear sources in 2004?
Your answer should be compact. -5.24. What is the difference between the Electricity production(% of total) of Hydroelectric sources in 2003 and the Electricity production(% of total) of Renewable sources in 2004?
Ensure brevity in your answer.  0.18. What is the difference between the Electricity production(% of total) in Nuclear sources in 2003 and the Electricity production(% of total) in Renewable sources in 2004?
Give a very brief answer. 5.35. What is the average Electricity production(% of total) in Hydroelectric sources per year?
Make the answer very short. 0.68. What is the average Electricity production(% of total) of Nuclear sources per year?
Offer a terse response. 5.89. What is the average Electricity production(% of total) in Renewable sources per year?
Provide a short and direct response. 0.11. In the year 1996, what is the difference between the Electricity production(% of total) in Hydroelectric sources and Electricity production(% of total) in Nuclear sources?
Your answer should be compact. -5.24. In the year 1996, what is the difference between the Electricity production(% of total) in Hydroelectric sources and Electricity production(% of total) in Renewable sources?
Make the answer very short. 0.63. In the year 1996, what is the difference between the Electricity production(% of total) in Nuclear sources and Electricity production(% of total) in Renewable sources?
Your answer should be very brief. 5.87. In the year 1997, what is the difference between the Electricity production(% of total) of Hydroelectric sources and Electricity production(% of total) of Nuclear sources?
Offer a very short reply. -5.08. In the year 1997, what is the difference between the Electricity production(% of total) in Hydroelectric sources and Electricity production(% of total) in Renewable sources?
Provide a succinct answer. 0.94. In the year 1997, what is the difference between the Electricity production(% of total) in Nuclear sources and Electricity production(% of total) in Renewable sources?
Keep it short and to the point. 6.02. In the year 1998, what is the difference between the Electricity production(% of total) of Hydroelectric sources and Electricity production(% of total) of Nuclear sources?
Ensure brevity in your answer.  -5.92. In the year 1998, what is the difference between the Electricity production(% of total) in Hydroelectric sources and Electricity production(% of total) in Renewable sources?
Provide a succinct answer. 0.67. In the year 1998, what is the difference between the Electricity production(% of total) of Nuclear sources and Electricity production(% of total) of Renewable sources?
Ensure brevity in your answer.  6.59. In the year 1999, what is the difference between the Electricity production(% of total) of Hydroelectric sources and Electricity production(% of total) of Nuclear sources?
Ensure brevity in your answer.  -6.04. In the year 1999, what is the difference between the Electricity production(% of total) of Hydroelectric sources and Electricity production(% of total) of Renewable sources?
Your answer should be compact. 0.26. In the year 1999, what is the difference between the Electricity production(% of total) of Nuclear sources and Electricity production(% of total) of Renewable sources?
Offer a very short reply. 6.31. In the year 2000, what is the difference between the Electricity production(% of total) of Hydroelectric sources and Electricity production(% of total) of Nuclear sources?
Ensure brevity in your answer.  -5.73. In the year 2000, what is the difference between the Electricity production(% of total) in Hydroelectric sources and Electricity production(% of total) in Renewable sources?
Ensure brevity in your answer.  0.38. In the year 2000, what is the difference between the Electricity production(% of total) in Nuclear sources and Electricity production(% of total) in Renewable sources?
Your response must be concise. 6.11. In the year 2001, what is the difference between the Electricity production(% of total) of Hydroelectric sources and Electricity production(% of total) of Nuclear sources?
Offer a terse response. -4.2. In the year 2001, what is the difference between the Electricity production(% of total) in Hydroelectric sources and Electricity production(% of total) in Renewable sources?
Keep it short and to the point. 0.81. In the year 2001, what is the difference between the Electricity production(% of total) of Nuclear sources and Electricity production(% of total) of Renewable sources?
Keep it short and to the point. 5. In the year 2002, what is the difference between the Electricity production(% of total) of Hydroelectric sources and Electricity production(% of total) of Nuclear sources?
Offer a terse response. -4.4. In the year 2002, what is the difference between the Electricity production(% of total) in Hydroelectric sources and Electricity production(% of total) in Renewable sources?
Ensure brevity in your answer.  0.95. In the year 2002, what is the difference between the Electricity production(% of total) of Nuclear sources and Electricity production(% of total) of Renewable sources?
Your answer should be compact. 5.35. In the year 2003, what is the difference between the Electricity production(% of total) in Hydroelectric sources and Electricity production(% of total) in Nuclear sources?
Give a very brief answer. -5.17. In the year 2003, what is the difference between the Electricity production(% of total) in Hydroelectric sources and Electricity production(% of total) in Renewable sources?
Give a very brief answer. 0.17. In the year 2003, what is the difference between the Electricity production(% of total) of Nuclear sources and Electricity production(% of total) of Renewable sources?
Offer a terse response. 5.35. In the year 2004, what is the difference between the Electricity production(% of total) in Hydroelectric sources and Electricity production(% of total) in Nuclear sources?
Your response must be concise. -5.15. In the year 2004, what is the difference between the Electricity production(% of total) in Hydroelectric sources and Electricity production(% of total) in Renewable sources?
Make the answer very short. 0.27. In the year 2004, what is the difference between the Electricity production(% of total) in Nuclear sources and Electricity production(% of total) in Renewable sources?
Your response must be concise. 5.42. What is the ratio of the Electricity production(% of total) of Hydroelectric sources in 1996 to that in 1997?
Offer a very short reply. 0.66. What is the ratio of the Electricity production(% of total) of Nuclear sources in 1996 to that in 1997?
Provide a succinct answer. 0.97. What is the ratio of the Electricity production(% of total) of Renewable sources in 1996 to that in 1997?
Provide a short and direct response. 0.43. What is the ratio of the Electricity production(% of total) in Hydroelectric sources in 1996 to that in 1998?
Provide a succinct answer. 0.84. What is the ratio of the Electricity production(% of total) of Nuclear sources in 1996 to that in 1998?
Make the answer very short. 0.88. What is the ratio of the Electricity production(% of total) of Renewable sources in 1996 to that in 1998?
Offer a terse response. 0.26. What is the ratio of the Electricity production(% of total) of Hydroelectric sources in 1996 to that in 1999?
Provide a succinct answer. 1.83. What is the ratio of the Electricity production(% of total) of Nuclear sources in 1996 to that in 1999?
Keep it short and to the point. 0.92. What is the ratio of the Electricity production(% of total) in Renewable sources in 1996 to that in 1999?
Offer a terse response. 0.31. What is the ratio of the Electricity production(% of total) of Hydroelectric sources in 1996 to that in 2000?
Ensure brevity in your answer.  1.25. What is the ratio of the Electricity production(% of total) of Nuclear sources in 1996 to that in 2000?
Make the answer very short. 0.94. What is the ratio of the Electricity production(% of total) of Renewable sources in 1996 to that in 2000?
Your answer should be very brief. 0.2. What is the ratio of the Electricity production(% of total) in Hydroelectric sources in 1996 to that in 2001?
Provide a succinct answer. 0.69. What is the ratio of the Electricity production(% of total) in Nuclear sources in 1996 to that in 2001?
Your answer should be very brief. 1.15. What is the ratio of the Electricity production(% of total) in Renewable sources in 1996 to that in 2001?
Provide a short and direct response. 0.2. What is the ratio of the Electricity production(% of total) in Hydroelectric sources in 1996 to that in 2002?
Offer a very short reply. 0.61. What is the ratio of the Electricity production(% of total) in Nuclear sources in 1996 to that in 2002?
Give a very brief answer. 1.08. What is the ratio of the Electricity production(% of total) of Renewable sources in 1996 to that in 2002?
Provide a succinct answer. 0.22. What is the ratio of the Electricity production(% of total) in Hydroelectric sources in 1996 to that in 2003?
Keep it short and to the point. 2.18. What is the ratio of the Electricity production(% of total) in Nuclear sources in 1996 to that in 2003?
Provide a succinct answer. 1.08. What is the ratio of the Electricity production(% of total) of Renewable sources in 1996 to that in 2003?
Ensure brevity in your answer.  0.23. What is the ratio of the Electricity production(% of total) of Hydroelectric sources in 1996 to that in 2004?
Provide a short and direct response. 1.68. What is the ratio of the Electricity production(% of total) of Nuclear sources in 1996 to that in 2004?
Provide a succinct answer. 1.06. What is the ratio of the Electricity production(% of total) in Renewable sources in 1996 to that in 2004?
Ensure brevity in your answer.  0.24. What is the ratio of the Electricity production(% of total) in Hydroelectric sources in 1997 to that in 1998?
Make the answer very short. 1.28. What is the ratio of the Electricity production(% of total) of Nuclear sources in 1997 to that in 1998?
Offer a very short reply. 0.91. What is the ratio of the Electricity production(% of total) of Renewable sources in 1997 to that in 1998?
Offer a very short reply. 0.62. What is the ratio of the Electricity production(% of total) in Hydroelectric sources in 1997 to that in 1999?
Give a very brief answer. 2.78. What is the ratio of the Electricity production(% of total) of Nuclear sources in 1997 to that in 1999?
Provide a succinct answer. 0.95. What is the ratio of the Electricity production(% of total) of Renewable sources in 1997 to that in 1999?
Offer a very short reply. 0.71. What is the ratio of the Electricity production(% of total) of Hydroelectric sources in 1997 to that in 2000?
Provide a succinct answer. 1.9. What is the ratio of the Electricity production(% of total) of Nuclear sources in 1997 to that in 2000?
Provide a succinct answer. 0.97. What is the ratio of the Electricity production(% of total) of Renewable sources in 1997 to that in 2000?
Provide a short and direct response. 0.48. What is the ratio of the Electricity production(% of total) in Hydroelectric sources in 1997 to that in 2001?
Give a very brief answer. 1.06. What is the ratio of the Electricity production(% of total) of Nuclear sources in 1997 to that in 2001?
Give a very brief answer. 1.18. What is the ratio of the Electricity production(% of total) of Renewable sources in 1997 to that in 2001?
Give a very brief answer. 0.48. What is the ratio of the Electricity production(% of total) in Hydroelectric sources in 1997 to that in 2002?
Make the answer very short. 0.92. What is the ratio of the Electricity production(% of total) of Nuclear sources in 1997 to that in 2002?
Provide a succinct answer. 1.11. What is the ratio of the Electricity production(% of total) of Renewable sources in 1997 to that in 2002?
Your answer should be compact. 0.52. What is the ratio of the Electricity production(% of total) of Hydroelectric sources in 1997 to that in 2003?
Offer a terse response. 3.32. What is the ratio of the Electricity production(% of total) in Nuclear sources in 1997 to that in 2003?
Offer a very short reply. 1.11. What is the ratio of the Electricity production(% of total) in Renewable sources in 1997 to that in 2003?
Ensure brevity in your answer.  0.55. What is the ratio of the Electricity production(% of total) in Hydroelectric sources in 1997 to that in 2004?
Provide a short and direct response. 2.55. What is the ratio of the Electricity production(% of total) of Nuclear sources in 1997 to that in 2004?
Your answer should be very brief. 1.1. What is the ratio of the Electricity production(% of total) in Renewable sources in 1997 to that in 2004?
Your answer should be compact. 0.56. What is the ratio of the Electricity production(% of total) of Hydroelectric sources in 1998 to that in 1999?
Your response must be concise. 2.17. What is the ratio of the Electricity production(% of total) of Nuclear sources in 1998 to that in 1999?
Make the answer very short. 1.05. What is the ratio of the Electricity production(% of total) of Renewable sources in 1998 to that in 1999?
Your response must be concise. 1.16. What is the ratio of the Electricity production(% of total) of Hydroelectric sources in 1998 to that in 2000?
Keep it short and to the point. 1.48. What is the ratio of the Electricity production(% of total) in Nuclear sources in 1998 to that in 2000?
Ensure brevity in your answer.  1.07. What is the ratio of the Electricity production(% of total) in Renewable sources in 1998 to that in 2000?
Your response must be concise. 0.77. What is the ratio of the Electricity production(% of total) of Hydroelectric sources in 1998 to that in 2001?
Your response must be concise. 0.82. What is the ratio of the Electricity production(% of total) of Nuclear sources in 1998 to that in 2001?
Give a very brief answer. 1.3. What is the ratio of the Electricity production(% of total) in Renewable sources in 1998 to that in 2001?
Give a very brief answer. 0.77. What is the ratio of the Electricity production(% of total) in Hydroelectric sources in 1998 to that in 2002?
Keep it short and to the point. 0.72. What is the ratio of the Electricity production(% of total) of Nuclear sources in 1998 to that in 2002?
Your response must be concise. 1.22. What is the ratio of the Electricity production(% of total) in Renewable sources in 1998 to that in 2002?
Offer a very short reply. 0.83. What is the ratio of the Electricity production(% of total) of Hydroelectric sources in 1998 to that in 2003?
Provide a succinct answer. 2.59. What is the ratio of the Electricity production(% of total) of Nuclear sources in 1998 to that in 2003?
Give a very brief answer. 1.22. What is the ratio of the Electricity production(% of total) in Renewable sources in 1998 to that in 2003?
Provide a succinct answer. 0.88. What is the ratio of the Electricity production(% of total) of Hydroelectric sources in 1998 to that in 2004?
Provide a short and direct response. 1.99. What is the ratio of the Electricity production(% of total) in Nuclear sources in 1998 to that in 2004?
Offer a very short reply. 1.21. What is the ratio of the Electricity production(% of total) of Renewable sources in 1998 to that in 2004?
Offer a very short reply. 0.91. What is the ratio of the Electricity production(% of total) in Hydroelectric sources in 1999 to that in 2000?
Your answer should be very brief. 0.68. What is the ratio of the Electricity production(% of total) in Nuclear sources in 1999 to that in 2000?
Make the answer very short. 1.02. What is the ratio of the Electricity production(% of total) of Renewable sources in 1999 to that in 2000?
Give a very brief answer. 0.67. What is the ratio of the Electricity production(% of total) in Hydroelectric sources in 1999 to that in 2001?
Provide a short and direct response. 0.38. What is the ratio of the Electricity production(% of total) of Nuclear sources in 1999 to that in 2001?
Provide a short and direct response. 1.24. What is the ratio of the Electricity production(% of total) in Renewable sources in 1999 to that in 2001?
Keep it short and to the point. 0.67. What is the ratio of the Electricity production(% of total) of Hydroelectric sources in 1999 to that in 2002?
Provide a short and direct response. 0.33. What is the ratio of the Electricity production(% of total) in Nuclear sources in 1999 to that in 2002?
Your response must be concise. 1.17. What is the ratio of the Electricity production(% of total) of Renewable sources in 1999 to that in 2002?
Your answer should be compact. 0.72. What is the ratio of the Electricity production(% of total) of Hydroelectric sources in 1999 to that in 2003?
Ensure brevity in your answer.  1.2. What is the ratio of the Electricity production(% of total) in Nuclear sources in 1999 to that in 2003?
Ensure brevity in your answer.  1.17. What is the ratio of the Electricity production(% of total) of Renewable sources in 1999 to that in 2003?
Offer a very short reply. 0.76. What is the ratio of the Electricity production(% of total) in Hydroelectric sources in 1999 to that in 2004?
Keep it short and to the point. 0.92. What is the ratio of the Electricity production(% of total) of Nuclear sources in 1999 to that in 2004?
Your answer should be very brief. 1.15. What is the ratio of the Electricity production(% of total) of Renewable sources in 1999 to that in 2004?
Give a very brief answer. 0.79. What is the ratio of the Electricity production(% of total) in Hydroelectric sources in 2000 to that in 2001?
Make the answer very short. 0.56. What is the ratio of the Electricity production(% of total) of Nuclear sources in 2000 to that in 2001?
Offer a very short reply. 1.22. What is the ratio of the Electricity production(% of total) in Renewable sources in 2000 to that in 2001?
Provide a succinct answer. 1. What is the ratio of the Electricity production(% of total) of Hydroelectric sources in 2000 to that in 2002?
Offer a terse response. 0.49. What is the ratio of the Electricity production(% of total) of Nuclear sources in 2000 to that in 2002?
Offer a terse response. 1.14. What is the ratio of the Electricity production(% of total) in Renewable sources in 2000 to that in 2002?
Your response must be concise. 1.08. What is the ratio of the Electricity production(% of total) of Hydroelectric sources in 2000 to that in 2003?
Give a very brief answer. 1.75. What is the ratio of the Electricity production(% of total) in Nuclear sources in 2000 to that in 2003?
Keep it short and to the point. 1.14. What is the ratio of the Electricity production(% of total) in Renewable sources in 2000 to that in 2003?
Give a very brief answer. 1.15. What is the ratio of the Electricity production(% of total) in Hydroelectric sources in 2000 to that in 2004?
Keep it short and to the point. 1.34. What is the ratio of the Electricity production(% of total) of Nuclear sources in 2000 to that in 2004?
Ensure brevity in your answer.  1.13. What is the ratio of the Electricity production(% of total) of Renewable sources in 2000 to that in 2004?
Provide a short and direct response. 1.18. What is the ratio of the Electricity production(% of total) in Hydroelectric sources in 2001 to that in 2002?
Your answer should be compact. 0.87. What is the ratio of the Electricity production(% of total) in Nuclear sources in 2001 to that in 2002?
Keep it short and to the point. 0.94. What is the ratio of the Electricity production(% of total) of Renewable sources in 2001 to that in 2002?
Keep it short and to the point. 1.08. What is the ratio of the Electricity production(% of total) of Hydroelectric sources in 2001 to that in 2003?
Ensure brevity in your answer.  3.15. What is the ratio of the Electricity production(% of total) of Nuclear sources in 2001 to that in 2003?
Offer a terse response. 0.94. What is the ratio of the Electricity production(% of total) of Renewable sources in 2001 to that in 2003?
Offer a very short reply. 1.14. What is the ratio of the Electricity production(% of total) in Hydroelectric sources in 2001 to that in 2004?
Your answer should be very brief. 2.42. What is the ratio of the Electricity production(% of total) in Nuclear sources in 2001 to that in 2004?
Make the answer very short. 0.93. What is the ratio of the Electricity production(% of total) of Renewable sources in 2001 to that in 2004?
Offer a terse response. 1.18. What is the ratio of the Electricity production(% of total) in Hydroelectric sources in 2002 to that in 2003?
Provide a short and direct response. 3.6. What is the ratio of the Electricity production(% of total) of Renewable sources in 2002 to that in 2003?
Make the answer very short. 1.06. What is the ratio of the Electricity production(% of total) of Hydroelectric sources in 2002 to that in 2004?
Offer a terse response. 2.77. What is the ratio of the Electricity production(% of total) in Renewable sources in 2002 to that in 2004?
Offer a very short reply. 1.09. What is the ratio of the Electricity production(% of total) of Hydroelectric sources in 2003 to that in 2004?
Make the answer very short. 0.77. What is the ratio of the Electricity production(% of total) in Nuclear sources in 2003 to that in 2004?
Give a very brief answer. 0.99. What is the ratio of the Electricity production(% of total) in Renewable sources in 2003 to that in 2004?
Provide a succinct answer. 1.03. What is the difference between the highest and the second highest Electricity production(% of total) of Hydroelectric sources?
Make the answer very short. 0.08. What is the difference between the highest and the second highest Electricity production(% of total) in Nuclear sources?
Offer a very short reply. 0.3. What is the difference between the highest and the second highest Electricity production(% of total) in Renewable sources?
Ensure brevity in your answer.  0. What is the difference between the highest and the lowest Electricity production(% of total) in Hydroelectric sources?
Your answer should be compact. 0.79. What is the difference between the highest and the lowest Electricity production(% of total) in Nuclear sources?
Offer a terse response. 1.55. What is the difference between the highest and the lowest Electricity production(% of total) in Renewable sources?
Your answer should be very brief. 0.12. 